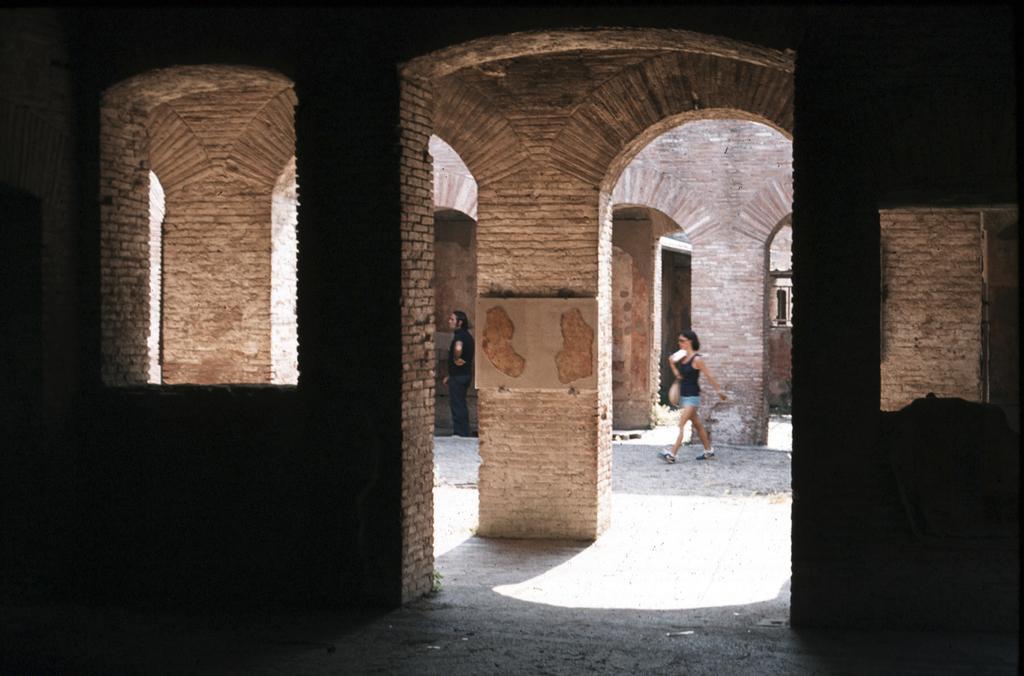Can you describe this image briefly? In this picture, it seems like arches and pillars in the foreground and people in the background. 